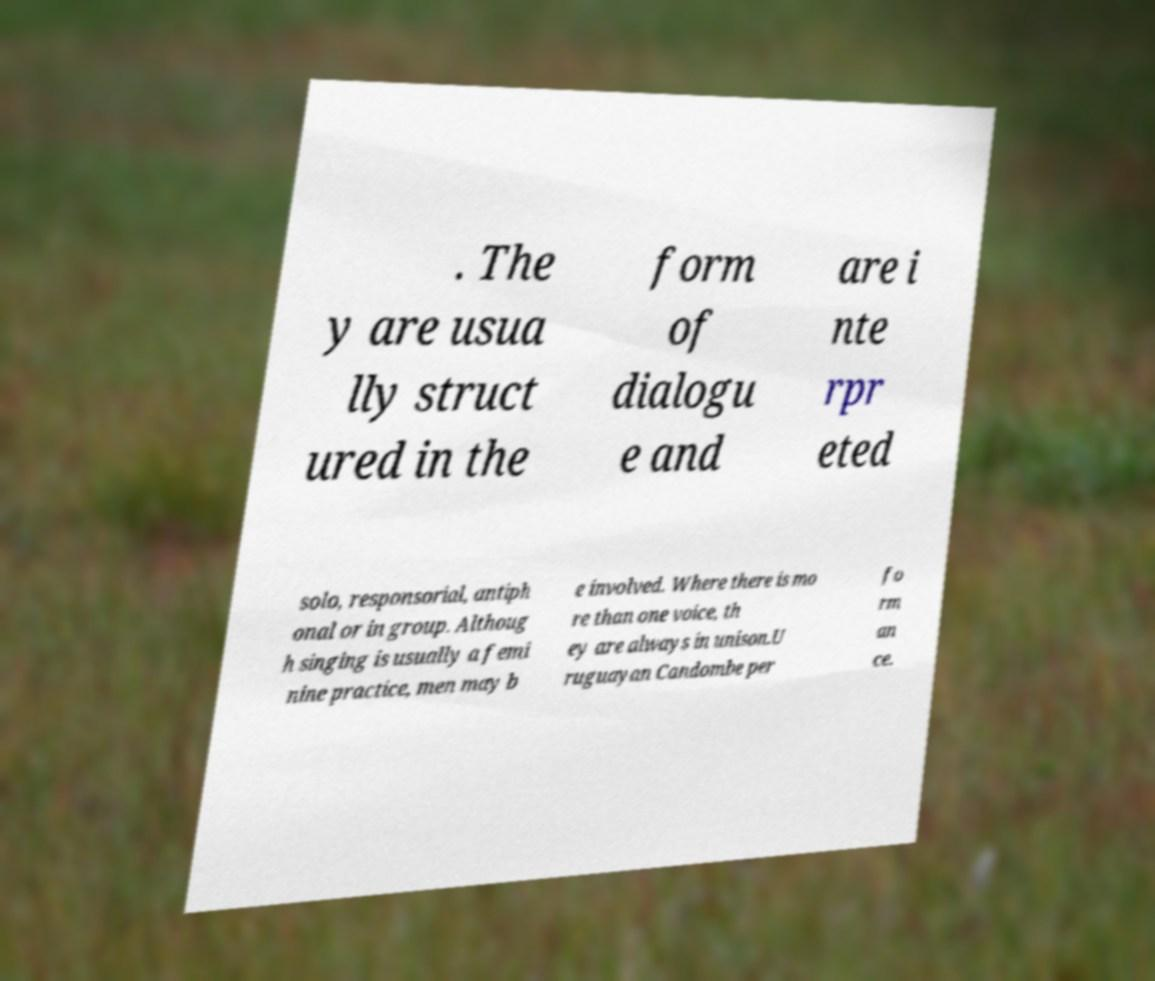Could you assist in decoding the text presented in this image and type it out clearly? . The y are usua lly struct ured in the form of dialogu e and are i nte rpr eted solo, responsorial, antiph onal or in group. Althoug h singing is usually a femi nine practice, men may b e involved. Where there is mo re than one voice, th ey are always in unison.U ruguayan Candombe per fo rm an ce. 